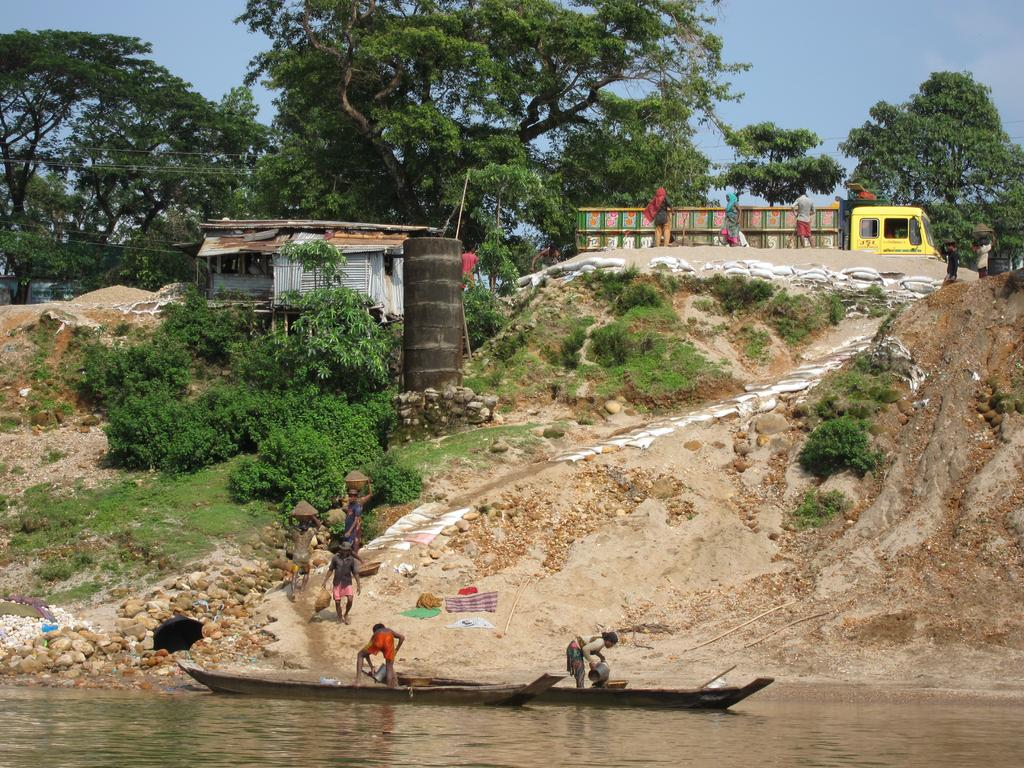What is located at the bottom of the image? There are boats on the water at the bottom of the image. What are the people in the boats doing? People are standing in the boats. What can be seen in the background of the image? There are people, a shed, a vehicle, trees, and the sky visible in the background of the image. What is the tendency of the square in the image? There is no square present in the image. What time of day is depicted in the image? The provided facts do not give any information about the time of day, so it cannot be determined from the image. 